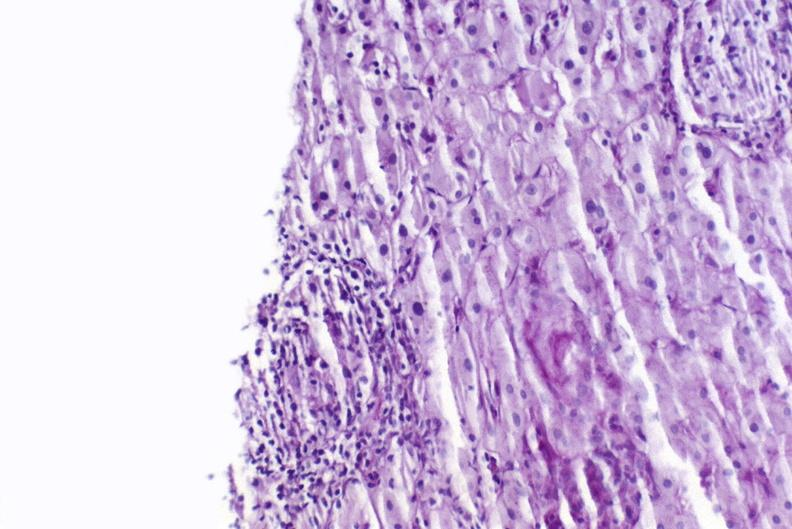s intraductal papillomatosis with apocrine metaplasia present?
Answer the question using a single word or phrase. No 